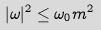<formula> <loc_0><loc_0><loc_500><loc_500>| \omega | ^ { 2 } \leq \omega _ { 0 } m ^ { 2 }</formula> 